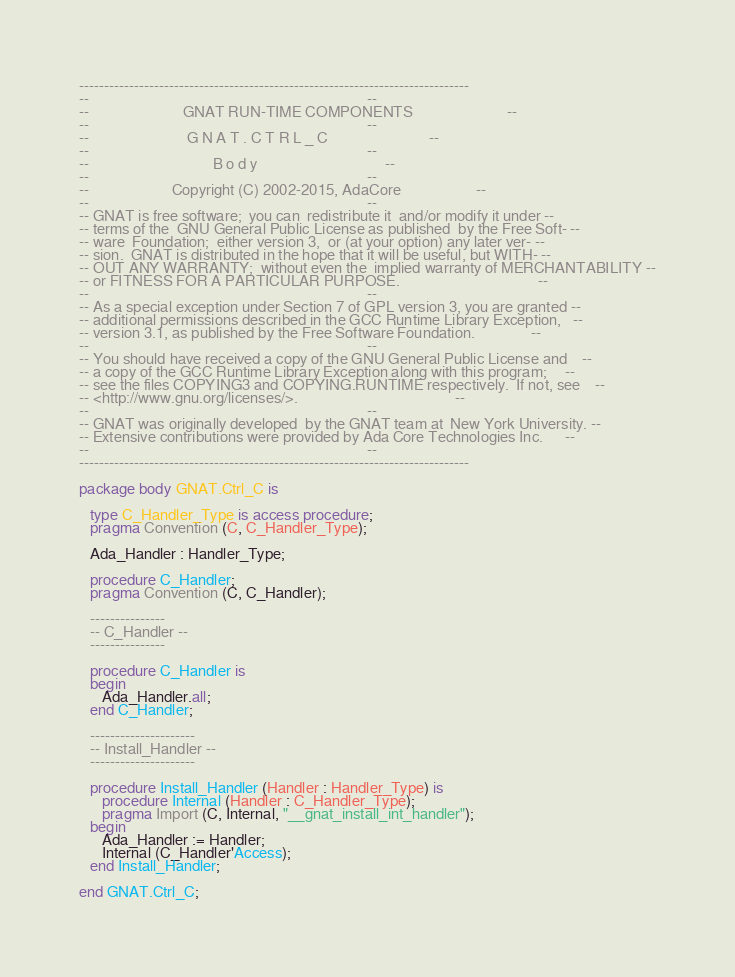<code> <loc_0><loc_0><loc_500><loc_500><_Ada_>------------------------------------------------------------------------------
--                                                                          --
--                         GNAT RUN-TIME COMPONENTS                         --
--                                                                          --
--                          G N A T . C T R L _ C                           --
--                                                                          --
--                                 B o d y                                  --
--                                                                          --
--                      Copyright (C) 2002-2015, AdaCore                    --
--                                                                          --
-- GNAT is free software;  you can  redistribute it  and/or modify it under --
-- terms of the  GNU General Public License as published  by the Free Soft- --
-- ware  Foundation;  either version 3,  or (at your option) any later ver- --
-- sion.  GNAT is distributed in the hope that it will be useful, but WITH- --
-- OUT ANY WARRANTY;  without even the  implied warranty of MERCHANTABILITY --
-- or FITNESS FOR A PARTICULAR PURPOSE.                                     --
--                                                                          --
-- As a special exception under Section 7 of GPL version 3, you are granted --
-- additional permissions described in the GCC Runtime Library Exception,   --
-- version 3.1, as published by the Free Software Foundation.               --
--                                                                          --
-- You should have received a copy of the GNU General Public License and    --
-- a copy of the GCC Runtime Library Exception along with this program;     --
-- see the files COPYING3 and COPYING.RUNTIME respectively.  If not, see    --
-- <http://www.gnu.org/licenses/>.                                          --
--                                                                          --
-- GNAT was originally developed  by the GNAT team at  New York University. --
-- Extensive contributions were provided by Ada Core Technologies Inc.      --
--                                                                          --
------------------------------------------------------------------------------

package body GNAT.Ctrl_C is

   type C_Handler_Type is access procedure;
   pragma Convention (C, C_Handler_Type);

   Ada_Handler : Handler_Type;

   procedure C_Handler;
   pragma Convention (C, C_Handler);

   ---------------
   -- C_Handler --
   ---------------

   procedure C_Handler is
   begin
      Ada_Handler.all;
   end C_Handler;

   ---------------------
   -- Install_Handler --
   ---------------------

   procedure Install_Handler (Handler : Handler_Type) is
      procedure Internal (Handler : C_Handler_Type);
      pragma Import (C, Internal, "__gnat_install_int_handler");
   begin
      Ada_Handler := Handler;
      Internal (C_Handler'Access);
   end Install_Handler;

end GNAT.Ctrl_C;
</code> 